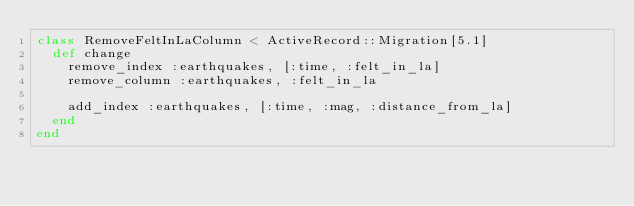Convert code to text. <code><loc_0><loc_0><loc_500><loc_500><_Ruby_>class RemoveFeltInLaColumn < ActiveRecord::Migration[5.1]
  def change
    remove_index :earthquakes, [:time, :felt_in_la]
    remove_column :earthquakes, :felt_in_la

    add_index :earthquakes, [:time, :mag, :distance_from_la]
  end
end
</code> 